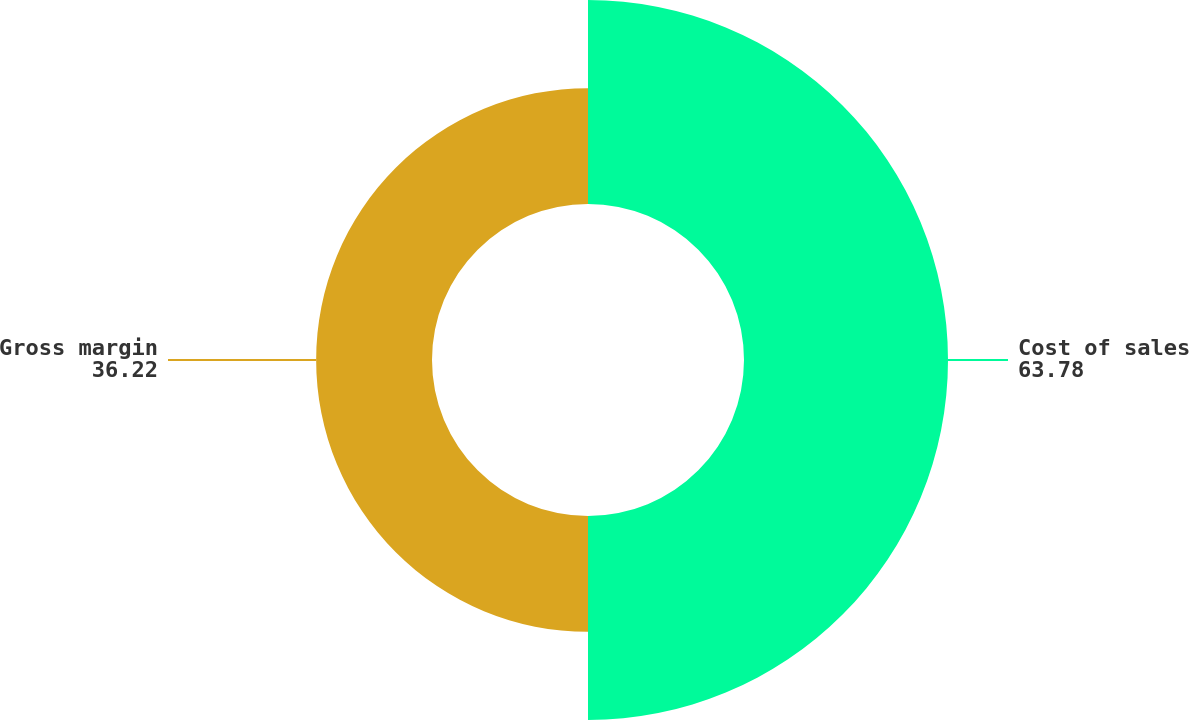Convert chart. <chart><loc_0><loc_0><loc_500><loc_500><pie_chart><fcel>Cost of sales<fcel>Gross margin<nl><fcel>63.78%<fcel>36.22%<nl></chart> 